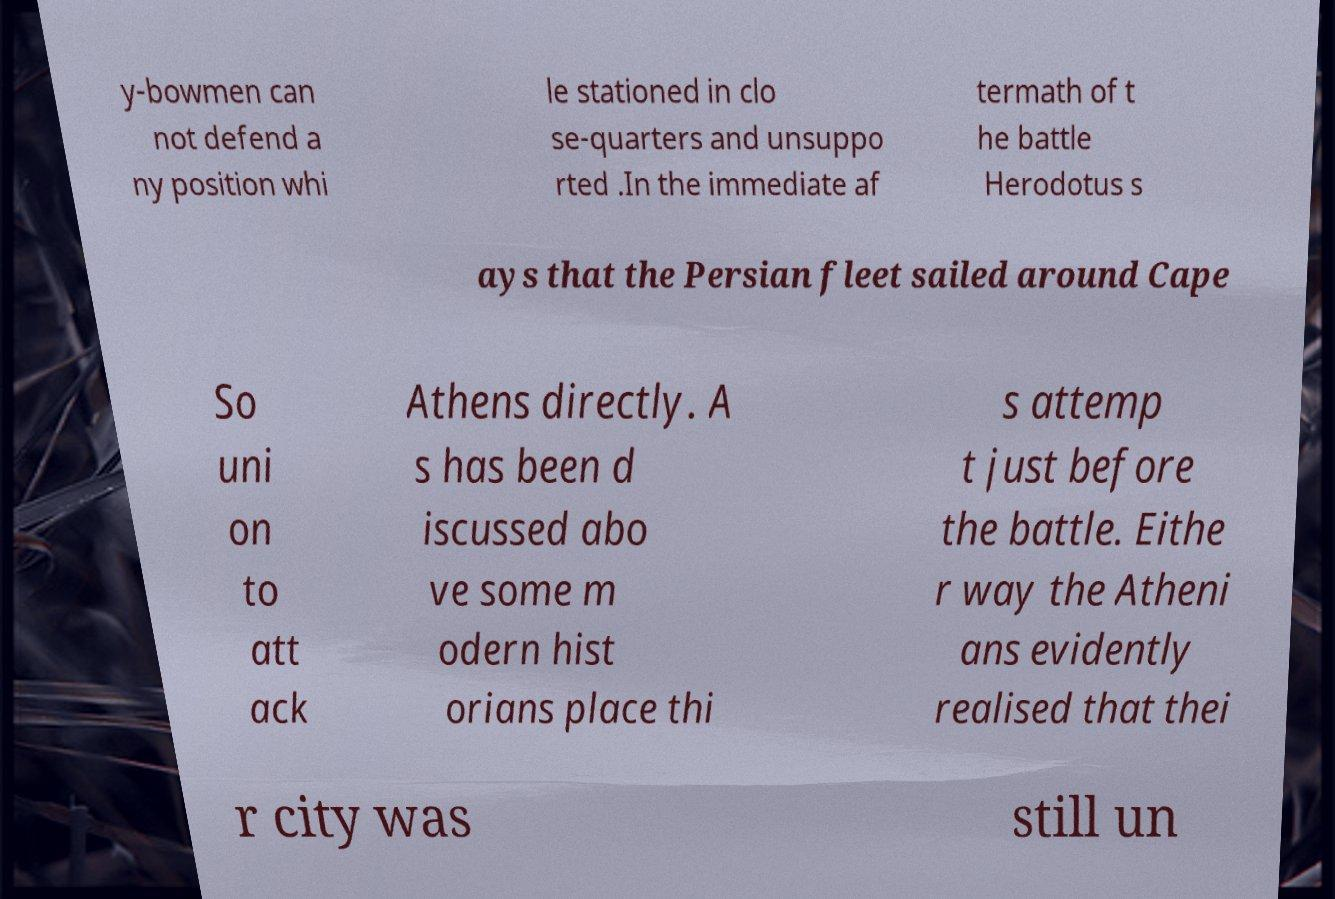Can you accurately transcribe the text from the provided image for me? y-bowmen can not defend a ny position whi le stationed in clo se-quarters and unsuppo rted .In the immediate af termath of t he battle Herodotus s ays that the Persian fleet sailed around Cape So uni on to att ack Athens directly. A s has been d iscussed abo ve some m odern hist orians place thi s attemp t just before the battle. Eithe r way the Atheni ans evidently realised that thei r city was still un 